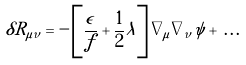Convert formula to latex. <formula><loc_0><loc_0><loc_500><loc_500>\delta R _ { \mu \nu } = - \left [ \frac { \epsilon } { f } + \frac { 1 } { 2 } \lambda \right ] \nabla _ { \mu } \nabla _ { \nu } \psi + \, . \, . \, .</formula> 